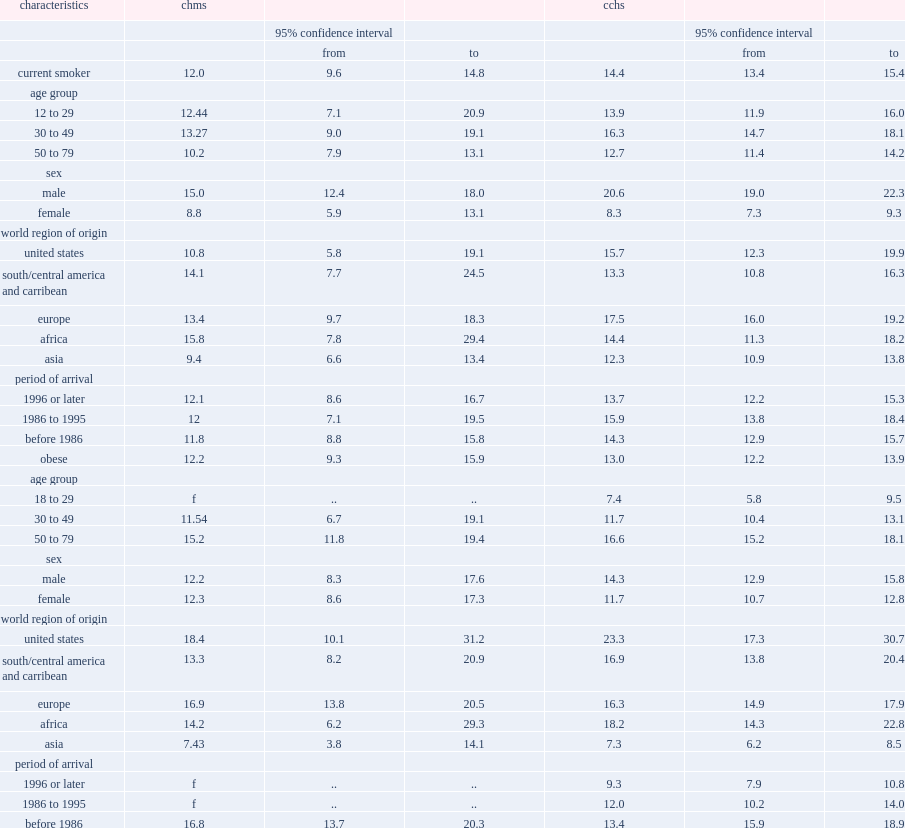Parse the table in full. {'header': ['characteristics', 'chms', '', '', 'cchs', '', ''], 'rows': [['', '', '95% confidence interval', '', '', '95% confidence interval', ''], ['', '', 'from', 'to', '', 'from', 'to'], ['current smoker', '12.0', '9.6', '14.8', '14.4', '13.4', '15.4'], ['age group', '', '', '', '', '', ''], ['12 to 29', '12.44', '7.1', '20.9', '13.9', '11.9', '16.0'], ['30 to 49', '13.27', '9.0', '19.1', '16.3', '14.7', '18.1'], ['50 to 79', '10.2', '7.9', '13.1', '12.7', '11.4', '14.2'], ['sex', '', '', '', '', '', ''], ['male', '15.0', '12.4', '18.0', '20.6', '19.0', '22.3'], ['female', '8.8', '5.9', '13.1', '8.3', '7.3', '9.3'], ['world region of origin', '', '', '', '', '', ''], ['united states', '10.8', '5.8', '19.1', '15.7', '12.3', '19.9'], ['south/central america and carribean', '14.1', '7.7', '24.5', '13.3', '10.8', '16.3'], ['europe', '13.4', '9.7', '18.3', '17.5', '16.0', '19.2'], ['africa', '15.8', '7.8', '29.4', '14.4', '11.3', '18.2'], ['asia', '9.4', '6.6', '13.4', '12.3', '10.9', '13.8'], ['period of arrival', '', '', '', '', '', ''], ['1996 or later', '12.1', '8.6', '16.7', '13.7', '12.2', '15.3'], ['1986 to 1995', '12', '7.1', '19.5', '15.9', '13.8', '18.4'], ['before 1986', '11.8', '8.8', '15.8', '14.3', '12.9', '15.7'], ['obese', '12.2', '9.3', '15.9', '13.0', '12.2', '13.9'], ['age group', '', '', '', '', '', ''], ['18 to 29', 'f', '..', '..', '7.4', '5.8', '9.5'], ['30 to 49', '11.54', '6.7', '19.1', '11.7', '10.4', '13.1'], ['50 to 79', '15.2', '11.8', '19.4', '16.6', '15.2', '18.1'], ['sex', '', '', '', '', '', ''], ['male', '12.2', '8.3', '17.6', '14.3', '12.9', '15.8'], ['female', '12.3', '8.6', '17.3', '11.7', '10.7', '12.8'], ['world region of origin', '', '', '', '', '', ''], ['united states', '18.4', '10.1', '31.2', '23.3', '17.3', '30.7'], ['south/central america and carribean', '13.3', '8.2', '20.9', '16.9', '13.8', '20.4'], ['europe', '16.9', '13.8', '20.5', '16.3', '14.9', '17.9'], ['africa', '14.2', '6.2', '29.3', '18.2', '14.3', '22.8'], ['asia', '7.43', '3.8', '14.1', '7.3', '6.2', '8.5'], ['period of arrival', '', '', '', '', '', ''], ['1996 or later', 'f', '..', '..', '9.3', '7.9', '10.8'], ['1986 to 1995', 'f', '..', '..', '12.0', '10.2', '14.0'], ['before 1986', '16.8', '13.7', '20.3', '13.4', '15.9', '18.9']]} What is the prevalence of immigrants aged 12 to 79 to be current smokers based on the chms? 12.0. What is the prevalence of immigrants aged 12 to 79 to be current smokers based on the cchs? 14.4. What is the prevalence of immigrant males to be current smokers based on the chms? 15.0. What is the prevalence of immigrant males to be current smokers based on the cchs? 20.6. Which one finds the prevalence of immigrant males to be current smokers is lower, the chms or the cchs? Chms. What is the chms estimates of the prevalence of obesity? 12.2. What is the cchs estimates of the prevalence of obesity? 13.0. 